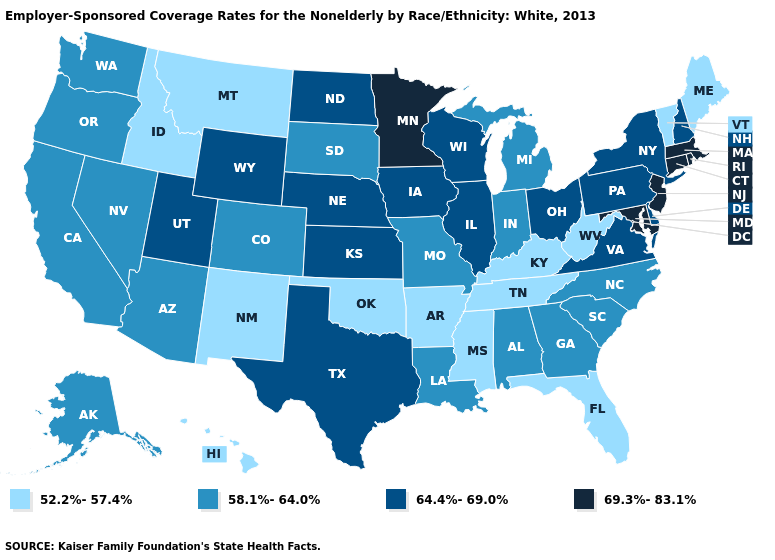Does the first symbol in the legend represent the smallest category?
Be succinct. Yes. What is the value of Maryland?
Concise answer only. 69.3%-83.1%. What is the highest value in the Northeast ?
Concise answer only. 69.3%-83.1%. What is the value of Arizona?
Keep it brief. 58.1%-64.0%. Does the first symbol in the legend represent the smallest category?
Short answer required. Yes. Does the map have missing data?
Concise answer only. No. Does the map have missing data?
Write a very short answer. No. Among the states that border Oklahoma , which have the lowest value?
Short answer required. Arkansas, New Mexico. What is the value of Maine?
Keep it brief. 52.2%-57.4%. Is the legend a continuous bar?
Concise answer only. No. What is the value of Idaho?
Quick response, please. 52.2%-57.4%. What is the value of Alaska?
Answer briefly. 58.1%-64.0%. Which states hav the highest value in the Northeast?
Quick response, please. Connecticut, Massachusetts, New Jersey, Rhode Island. What is the value of Vermont?
Write a very short answer. 52.2%-57.4%. Name the states that have a value in the range 52.2%-57.4%?
Write a very short answer. Arkansas, Florida, Hawaii, Idaho, Kentucky, Maine, Mississippi, Montana, New Mexico, Oklahoma, Tennessee, Vermont, West Virginia. 